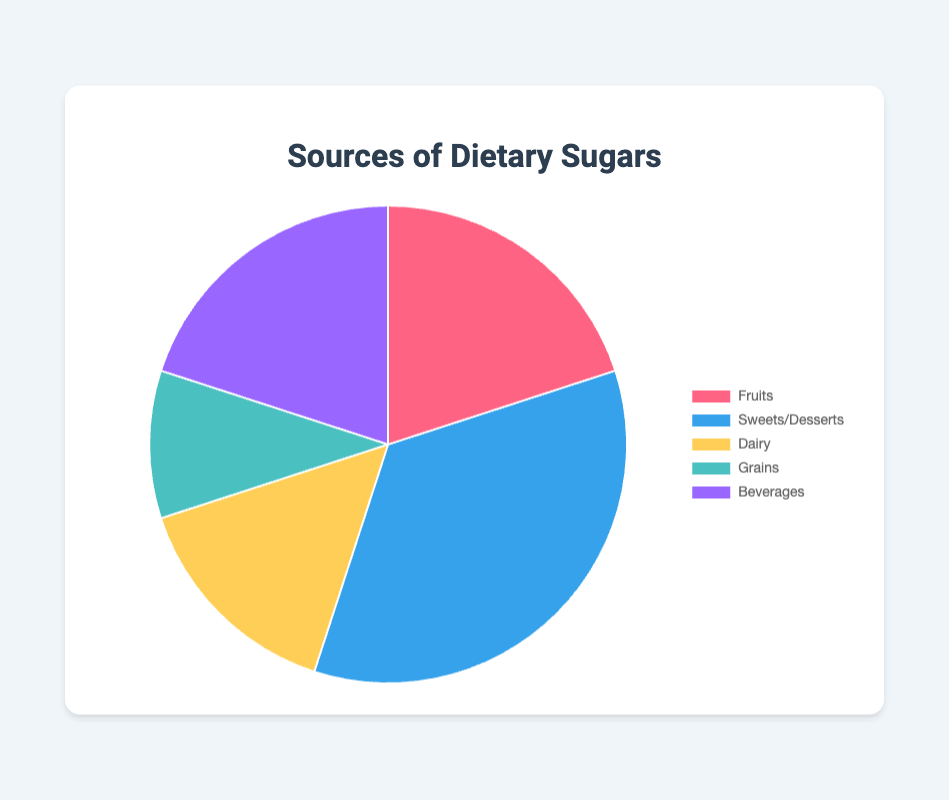What percentage of dietary sugars comes from fruits? The pie chart shows that fruits account for 20% of the total dietary sugars.
Answer: 20% Which category contributes the most to dietary sugars? By comparing the percentages of each category, sweets/desserts are the largest contributor with 35%.
Answer: Sweets/Desserts What's the combined percentage of dietary sugars from fruits and beverages? The percentages for fruits and beverages are 20% each. Adding these together, 20% + 20% = 40%.
Answer: 40% How much more do sweets/desserts contribute to dietary sugars compared to dairy? Sweets/Desserts contribute 35%, while dairy contributes 15%. The difference is 35% - 15% = 20%.
Answer: 20% Which categories each contribute exactly 20% to dietary sugars? The pie chart shows that both fruits and beverages each contribute 20%.
Answer: Fruits and Beverages How much less is the contribution from grains compared to the category with the highest percentage? The highest contributing category is sweets/desserts at 35%. Grains contribute 10%, so the difference is 35% - 10% = 25%.
Answer: 25% Which category's contribution is closest to dairy in terms of percentage? Dairy contributes 15%. The closest to this percentage is grains, which contribute 10%.
Answer: Grains If you combined the contributions of dairy and grains, would it be more or less than the contribution of sweets/desserts alone? Dairy contributes 15% and grains contribute 10%. Combined, they are 15% + 10% = 25%, which is less than the 35% contribution from sweets/desserts alone.
Answer: Less What is the visual color representing the beverages category in the pie chart? In the pie chart, beverages are represented by the color purple.
Answer: Purple Is the contribution from fruits greater than that from grains? The pie chart shows fruits contribute 20% and grains contribute 10%, so fruits contribute a greater percentage than grains.
Answer: Yes 